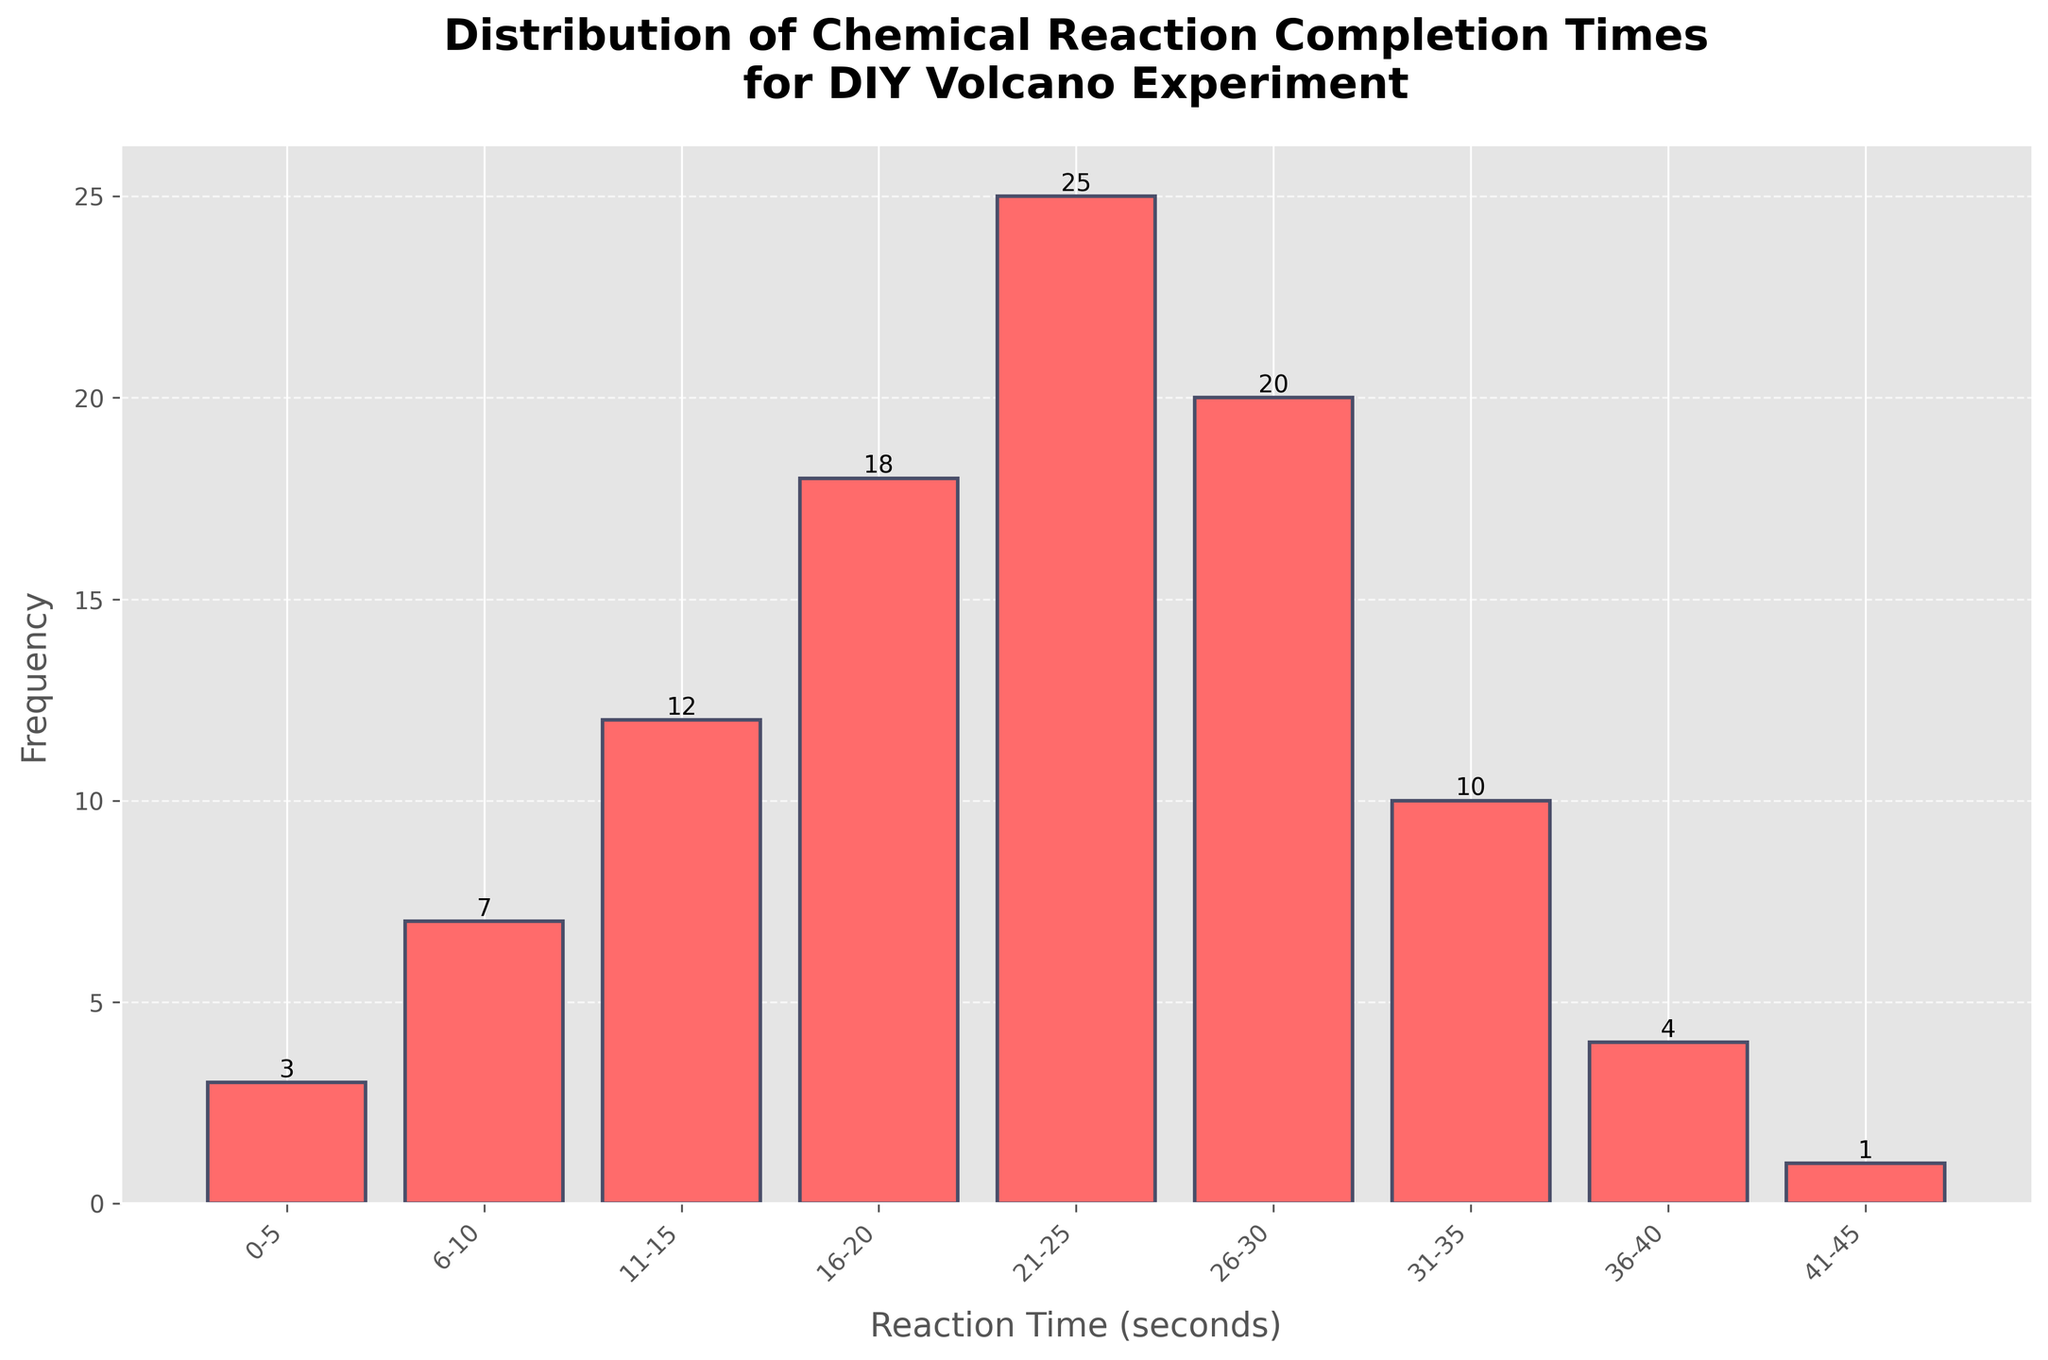What is the title of the histogram? The title is shown at the top of the histogram and reads 'Distribution of Chemical Reaction Completion Times for DIY Volcano Experiment'.
Answer: Distribution of Chemical Reaction Completion Times for DIY Volcano Experiment What does the x-axis represent? The x-axis represents the reaction time in seconds, divided into intervals like '0-5', '6-10', etc.
Answer: Reaction Time (seconds) What is the highest frequency recorded in the histogram, and what interval does it correspond to? By looking at the heights of the bars, the highest frequency recorded is 25, and it corresponds to the '21-25' seconds interval.
Answer: 25, 21-25 How many intervals are there in total in the histogram? The intervals can be counted along the x-axis from left to right. There are 9 intervals in total.
Answer: 9 What is the total frequency of reaction times between 16 and 30 seconds? Adding the frequencies of intervals '16-20', '21-25', and '26-30' which are 18, 25, and 20 respectively, gives the total frequency of 63.
Answer: 63 Which interval has a lower frequency: '0-5' seconds or '41-45' seconds? By comparing the heights of the bars for both intervals, the frequency for '0-5' seconds is 3, and for '41-45' seconds it is 1. Hence, '41-45' seconds has a lower frequency.
Answer: 41-45 seconds What is the approximate average frequency of the histogram? Summing all the frequencies (3 + 7 + 12 + 18 + 25 + 20 + 10 + 4 + 1 = 100) and dividing by the number of intervals (9) gives the average frequency, which is approximately 11.1.
Answer: 11.1 Which intervals have the same frequency? By observing the heights of the bars, '0-5' seconds (3) and '41-45' seconds (1) are unique, there are no other matches in this chart. Further review required for intervals like '36-40' does not repeat 4. Answer is no repeats.
Answer: None 